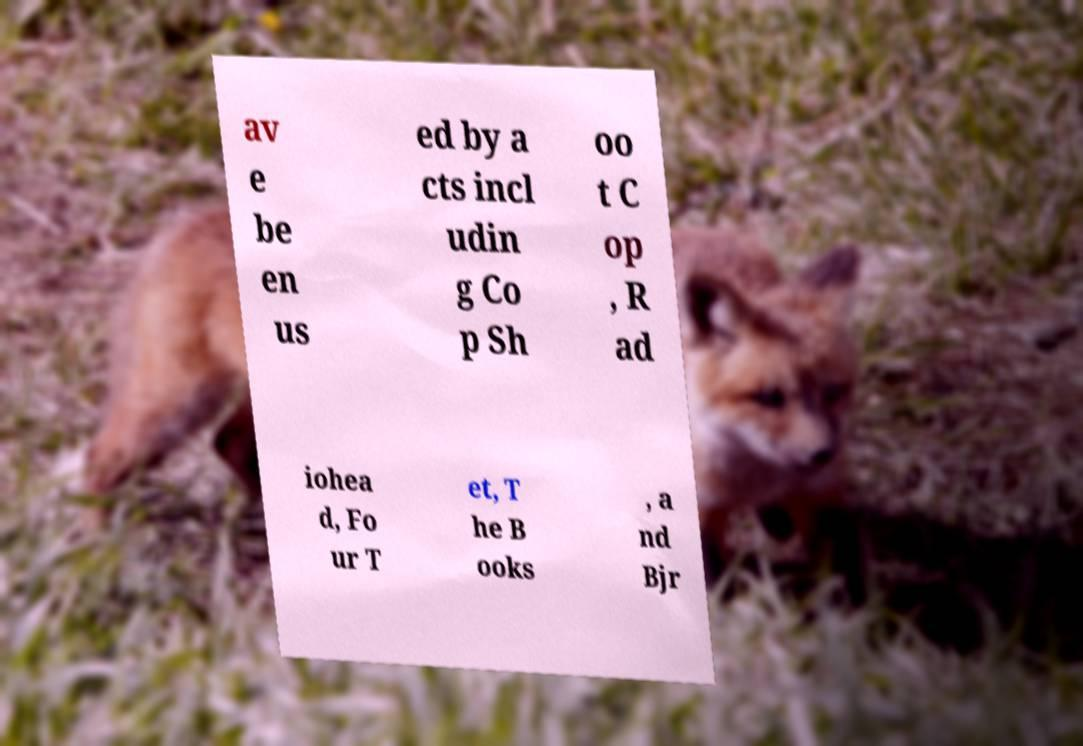For documentation purposes, I need the text within this image transcribed. Could you provide that? av e be en us ed by a cts incl udin g Co p Sh oo t C op , R ad iohea d, Fo ur T et, T he B ooks , a nd Bjr 